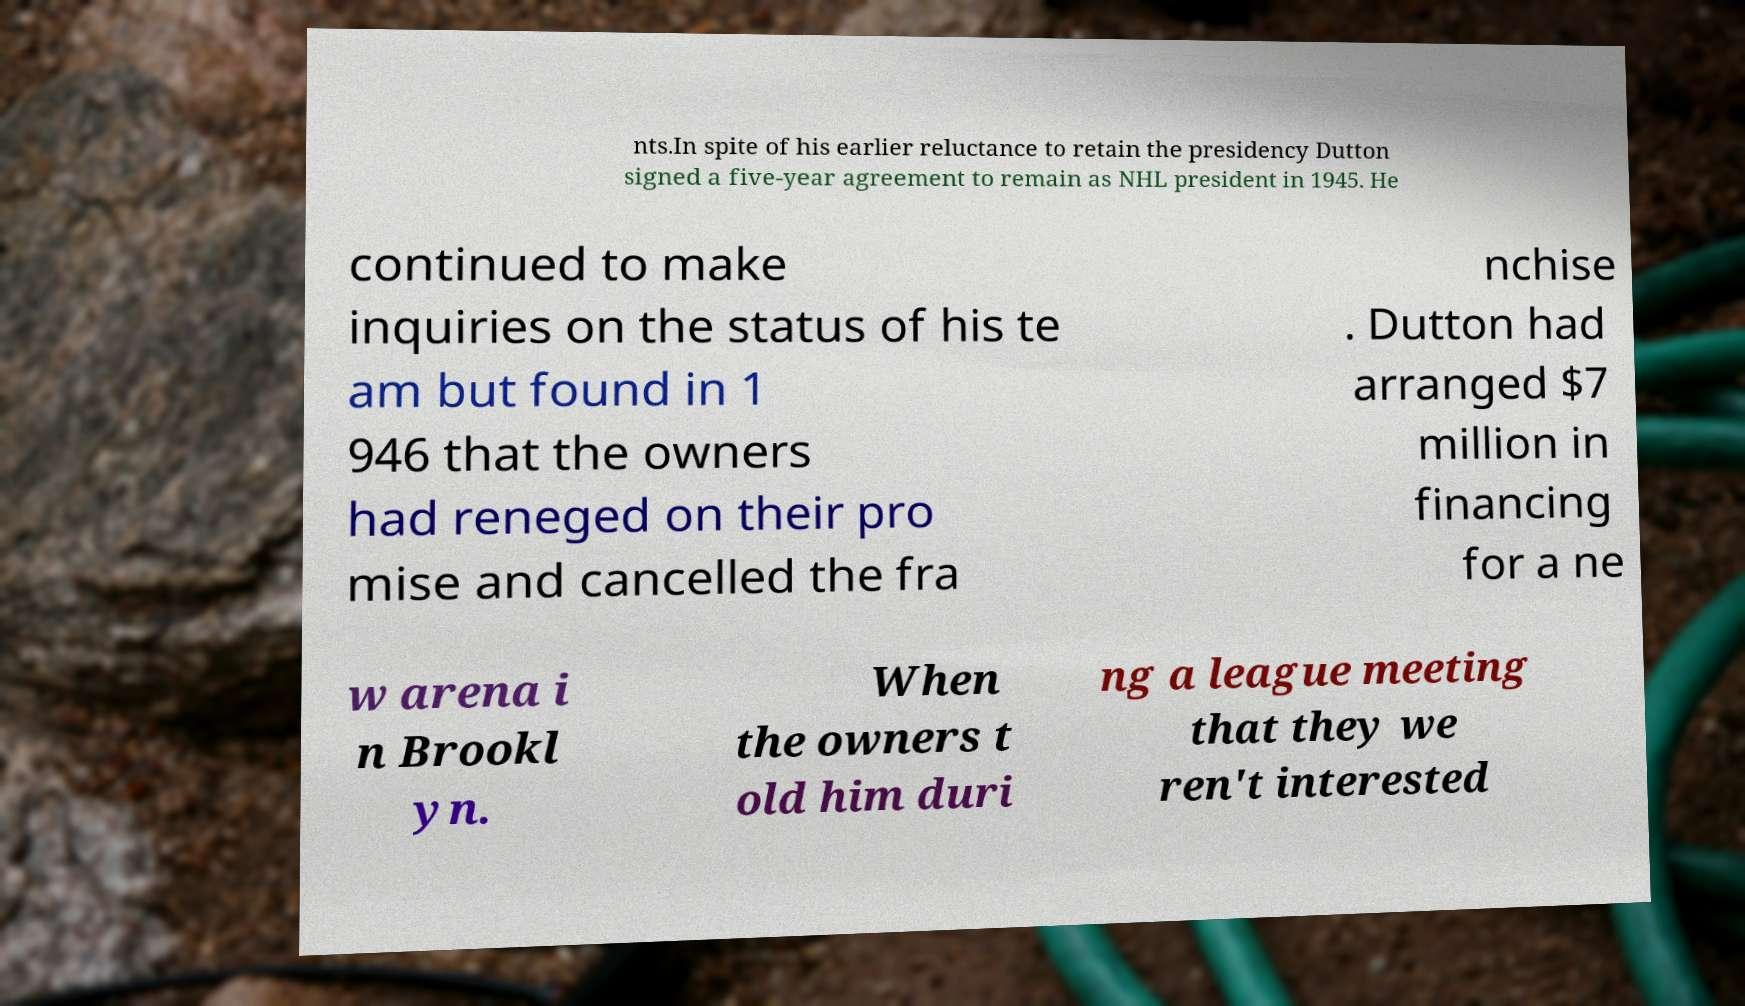Could you extract and type out the text from this image? nts.In spite of his earlier reluctance to retain the presidency Dutton signed a five-year agreement to remain as NHL president in 1945. He continued to make inquiries on the status of his te am but found in 1 946 that the owners had reneged on their pro mise and cancelled the fra nchise . Dutton had arranged $7 million in financing for a ne w arena i n Brookl yn. When the owners t old him duri ng a league meeting that they we ren't interested 